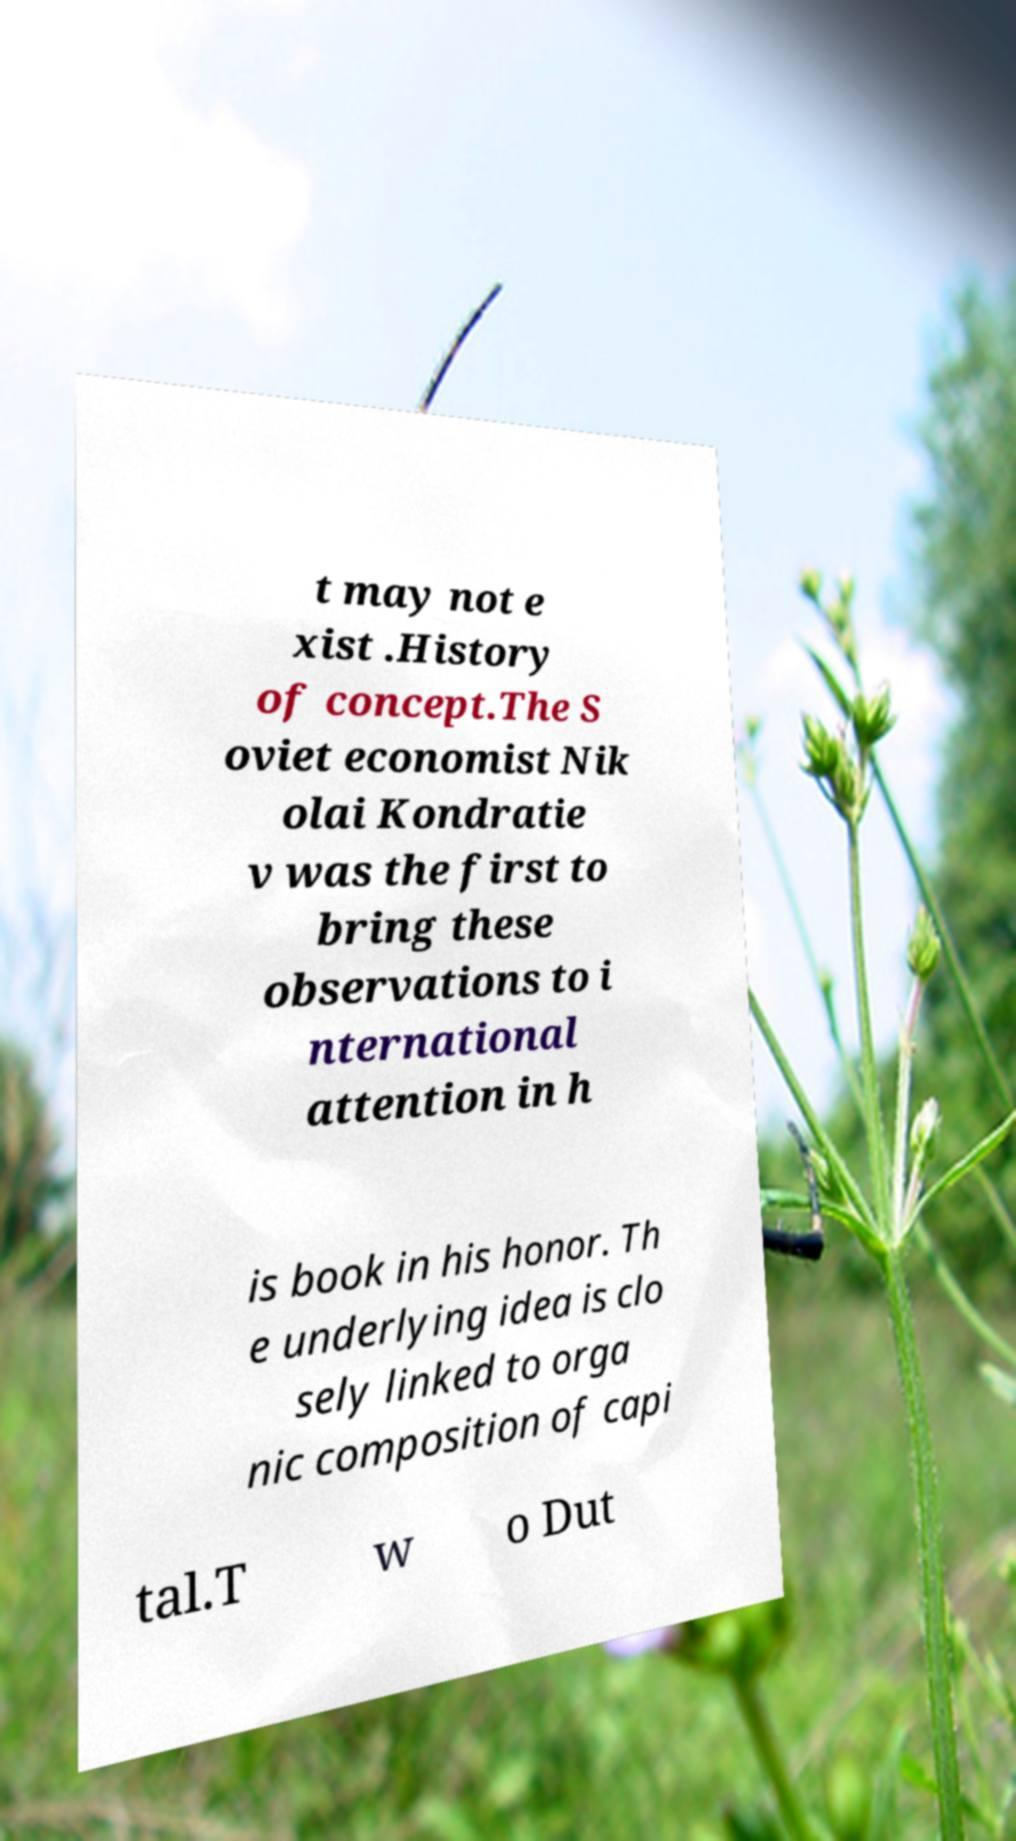Could you assist in decoding the text presented in this image and type it out clearly? t may not e xist .History of concept.The S oviet economist Nik olai Kondratie v was the first to bring these observations to i nternational attention in h is book in his honor. Th e underlying idea is clo sely linked to orga nic composition of capi tal.T w o Dut 